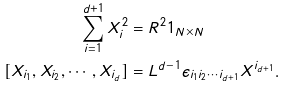<formula> <loc_0><loc_0><loc_500><loc_500>\sum _ { i = 1 } ^ { d + 1 } X _ { i } ^ { 2 } & = R ^ { 2 } { 1 } _ { N \times N } \\ [ X _ { i _ { 1 } } , X _ { i _ { 2 } } , \cdots , X _ { i _ { d } } ] & = { L } ^ { d - 1 } \epsilon _ { i _ { 1 } i _ { 2 } \cdots i _ { d + 1 } } X ^ { i _ { d + 1 } } .</formula> 